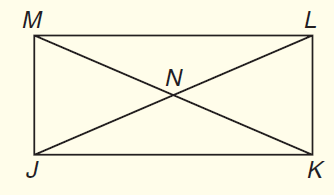Question: In rectangle J K L M shown below, J L and M K are diagonals. If J L = 2 x + 5 and K M = 4 x - 11, what is x?
Choices:
A. 5
B. 6
C. 8
D. 10
Answer with the letter. Answer: C 